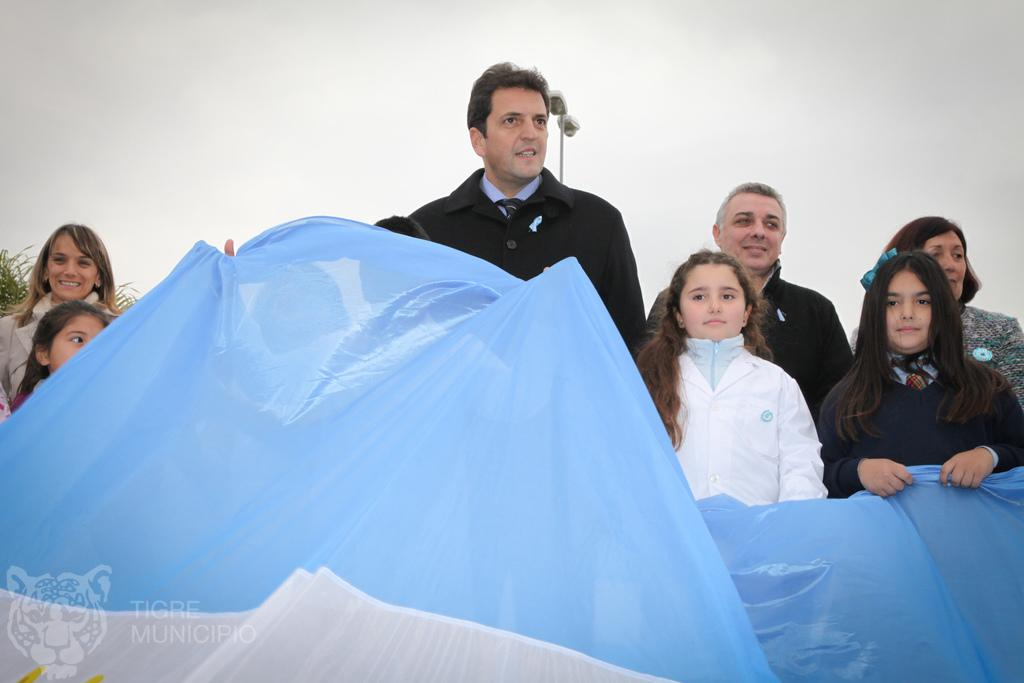What is happening in the image? There are people standing in the image. What color is the cloth that can be seen in the image? There is a blue color cloth in the image. What can be seen in the background of the image? The sky is visible in the background of the image. What object is present in the image that provides light? There is a light pole in the image. What type of paper is being used to create the icicle in the image? There is no paper or icicle present in the image. 